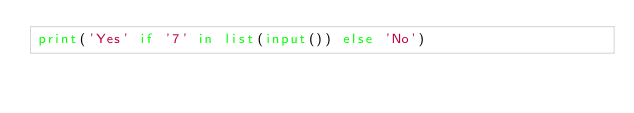<code> <loc_0><loc_0><loc_500><loc_500><_Python_>print('Yes' if '7' in list(input()) else 'No')</code> 